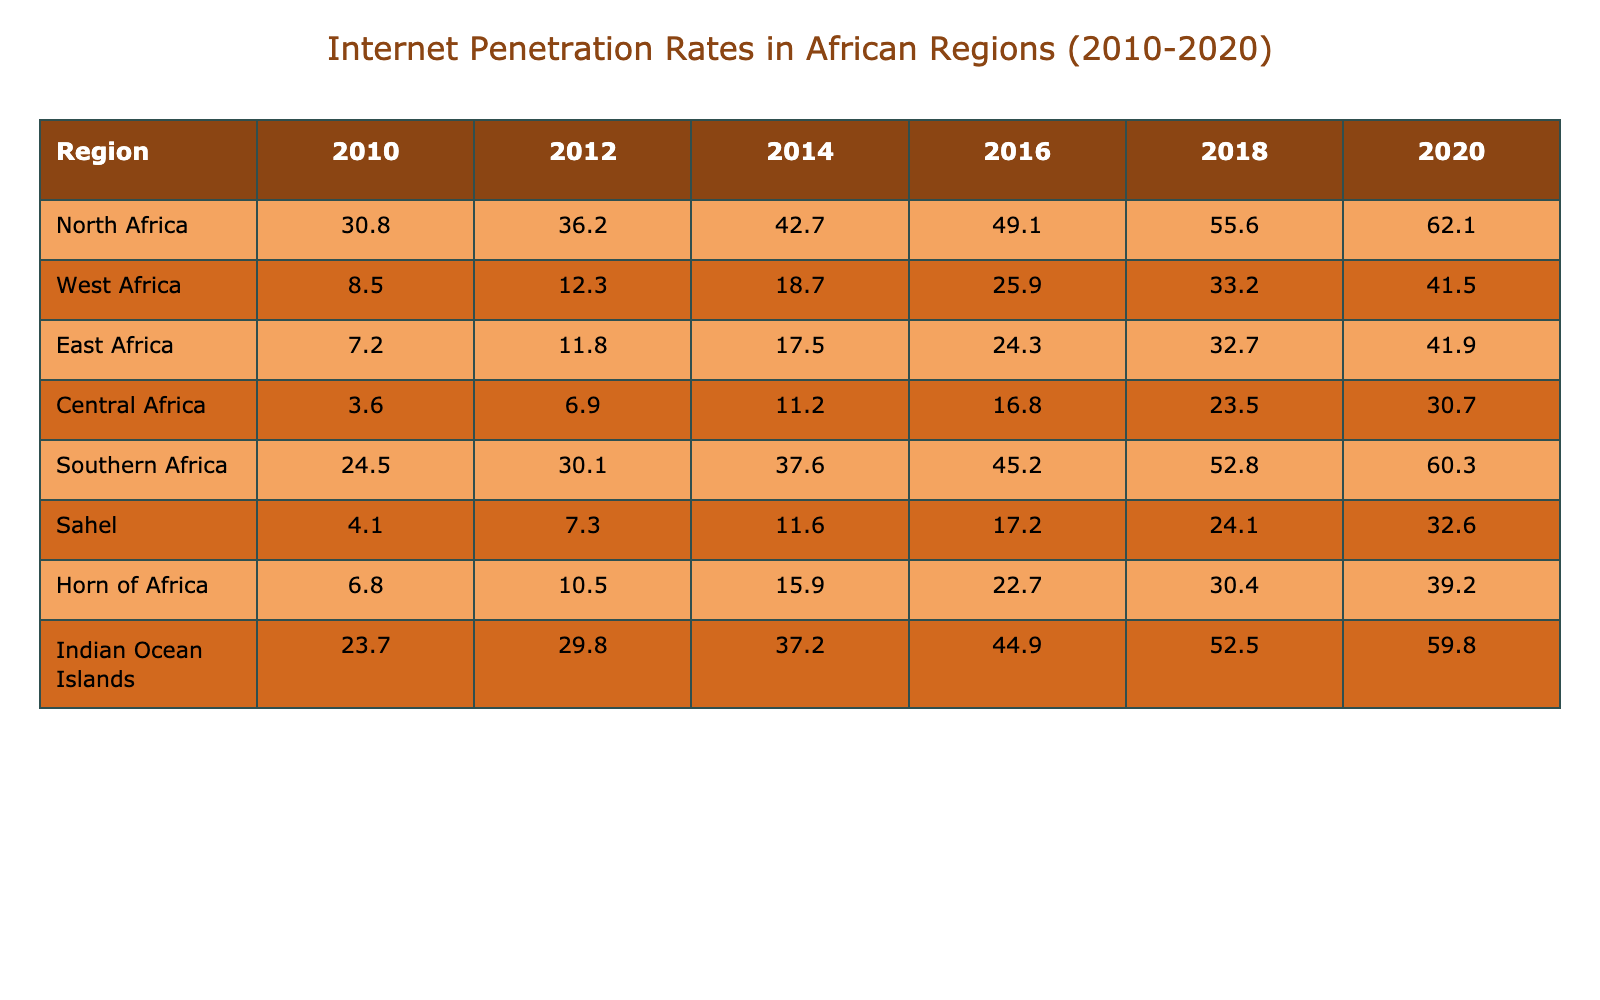What was the internet penetration rate in East Africa in 2020? In the table, we look for the value under "East Africa" in the year column for 2020. The value is 41.9.
Answer: 41.9 Which region had the highest internet penetration rate in 2018? By examining the table, we see the values for 2018: North Africa (55.6), West Africa (33.2), East Africa (32.7), Central Africa (23.5), Southern Africa (52.8), Sahel (24.1), Horn of Africa (30.4), and Indian Ocean Islands (52.5). The highest is North Africa at 55.6.
Answer: North Africa What is the difference in internet penetration rates between Central Africa in 2010 and 2020? The rate for Central Africa in 2010 is 3.6 and in 2020 it is 30.7. The difference is calculated as 30.7 - 3.6 = 27.1.
Answer: 27.1 Is the internet penetration rate in Southern Africa consistently increasing from 2010 to 2020? By examining each year's data for Southern Africa: 24.5, 30.1, 37.6, 45.2, 52.8, and 60.3, we see that each subsequent value is greater than the previous one, indicating a consistent increase.
Answer: Yes What was the average internet penetration rate in West Africa from 2010 to 2020? We sum the values for West Africa across the years: 8.5 + 12.3 + 18.7 + 25.9 + 33.2 + 41.5 = 140.1. Then, we divide by the number of years (6) to find the average: 140.1 / 6 = 23.35.
Answer: 23.35 Which region showed the least internet penetration in 2010? Looking at the data for 2010, Central Africa has the lowest value at 3.6, compared to the other regions.
Answer: Central Africa What was the increase in internet penetration for the Indian Ocean Islands from 2010 to 2020? The value for 2010 is 23.7 and for 2020 it is 59.8. The increase is calculated as 59.8 - 23.7 = 36.1.
Answer: 36.1 Did East Africa's internet penetration rate surpass that of West Africa in 2020? In 2020, East Africa had a rate of 41.9 while West Africa had a rate of 41.5. Since 41.9 is greater than 41.5, the statement is true.
Answer: Yes What was the total internet penetration rate for all regions combined in 2016? We sum the rates for each region in 2016: 49.1 (North Africa) + 25.9 (West Africa) + 24.3 (East Africa) + 16.8 (Central Africa) + 45.2 (Southern Africa) + 17.2 (Sahel) + 22.7 (Horn of Africa) + 44.9 (Indian Ocean Islands) = 224.1.
Answer: 224.1 Which region experienced the largest rate of increase in internet penetration from 2010 to 2020? By calculating the increases: North Africa: 62.1 - 30.8 = 31.3, West Africa: 41.5 - 8.5 = 33.0, East Africa: 41.9 - 7.2 = 34.7, Central Africa: 30.7 - 3.6 = 27.1, Southern Africa: 60.3 - 24.5 = 35.8, Sahel: 32.6 - 4.1 = 28.5, Horn of Africa: 39.2 - 6.8 = 32.4, Indian Ocean Islands: 59.8 - 23.7 = 36.1. East Africa shows the largest increase of 34.7.
Answer: East Africa 